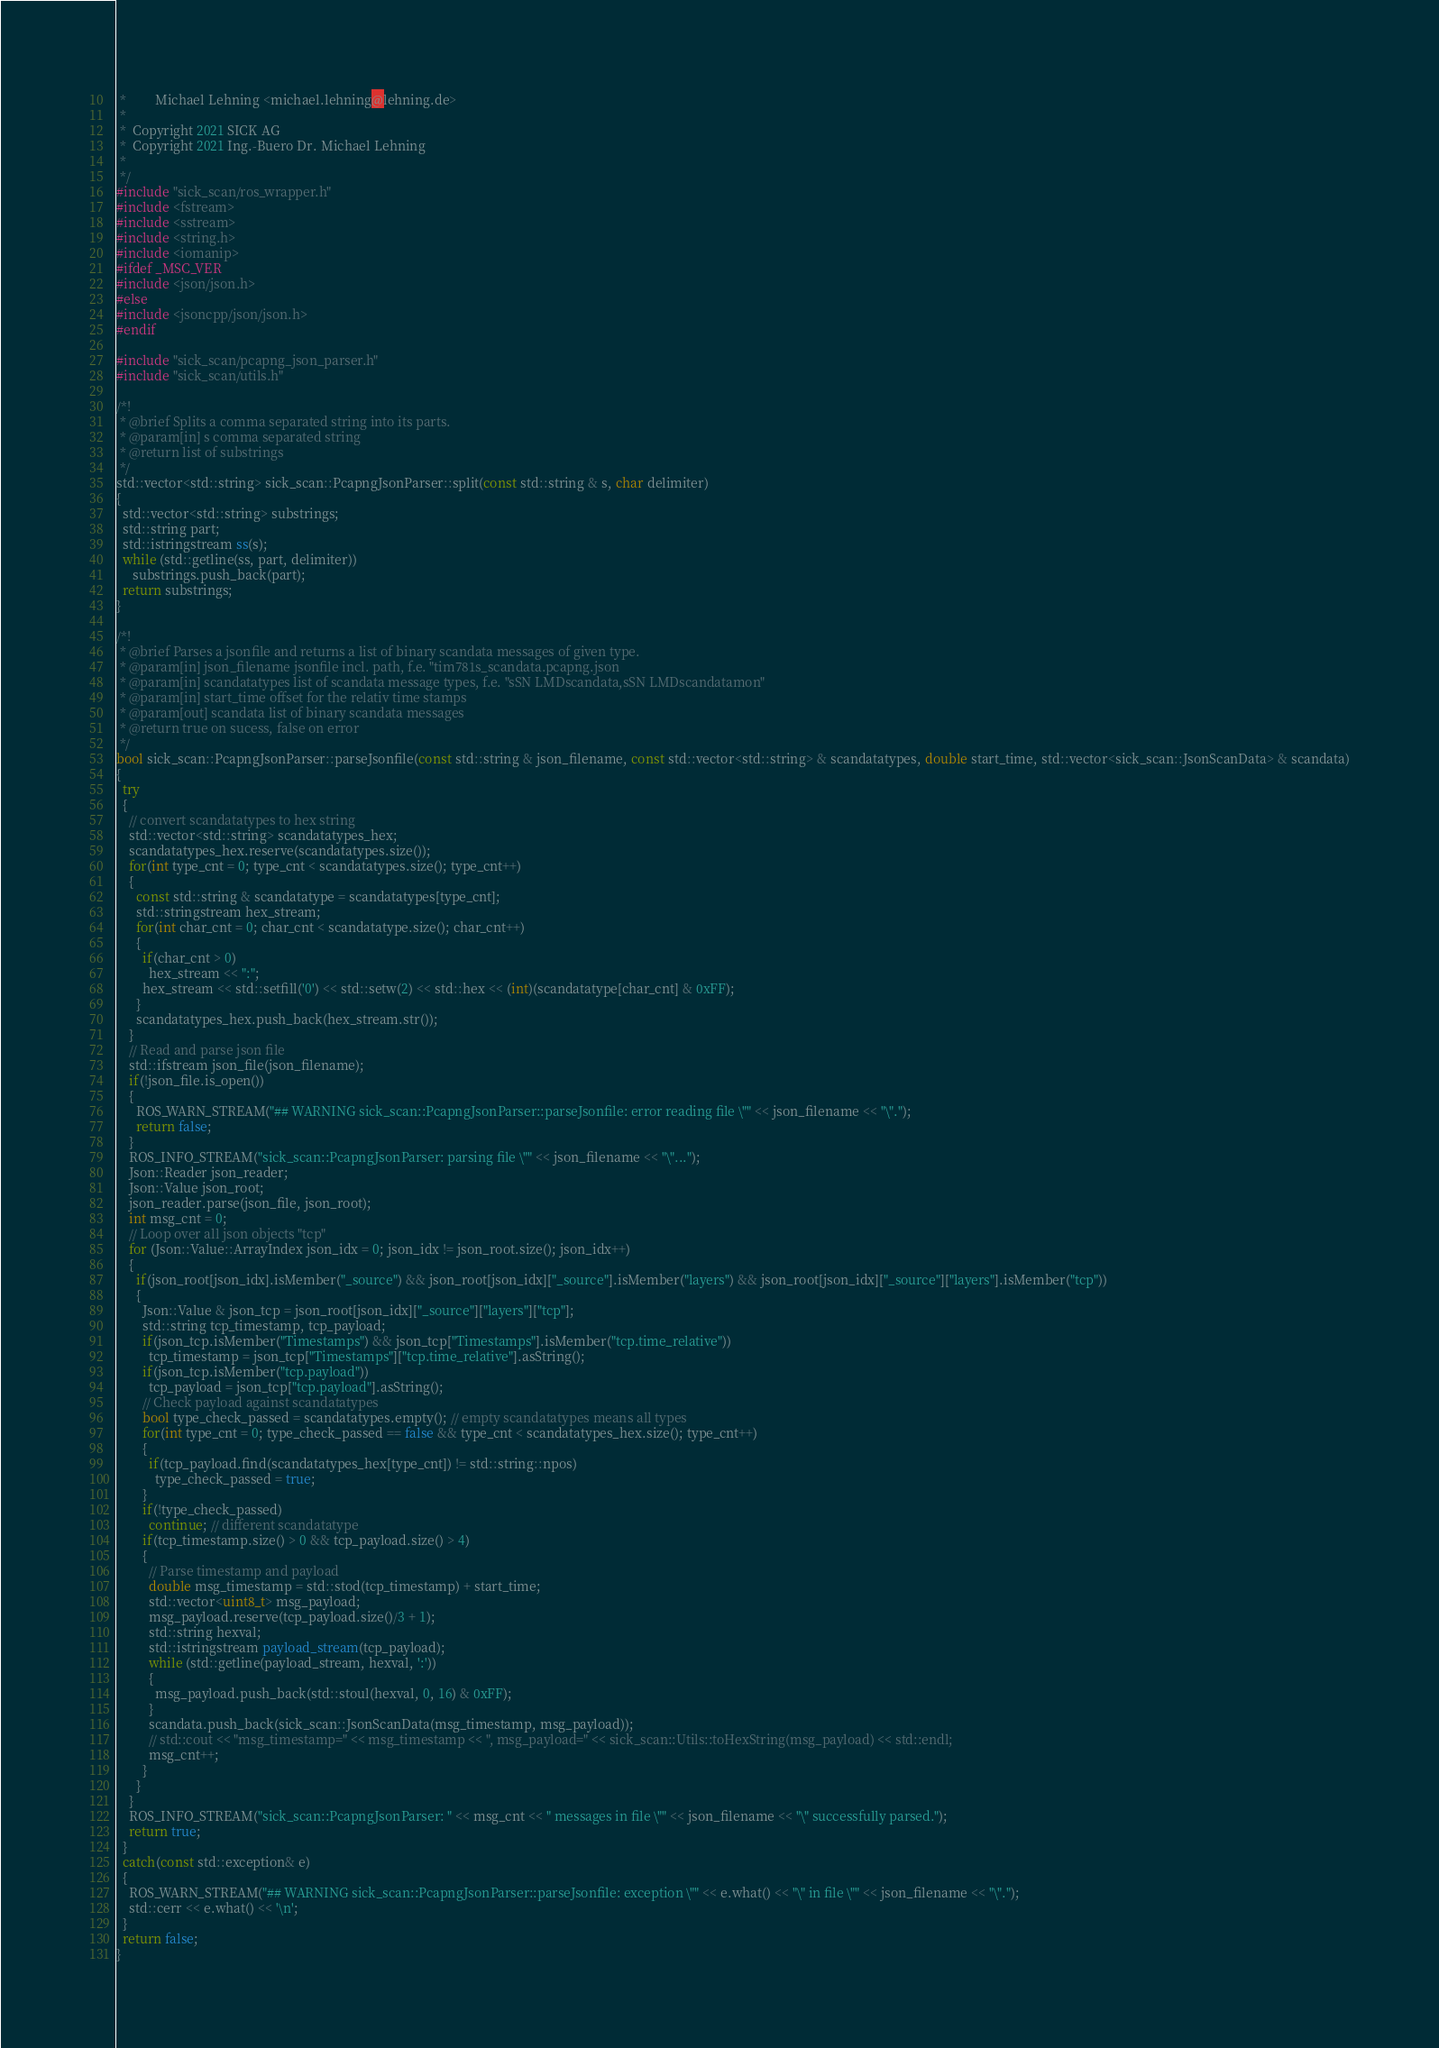Convert code to text. <code><loc_0><loc_0><loc_500><loc_500><_C++_> *         Michael Lehning <michael.lehning@lehning.de>
 *
 *  Copyright 2021 SICK AG
 *  Copyright 2021 Ing.-Buero Dr. Michael Lehning
 *
 */
#include "sick_scan/ros_wrapper.h"
#include <fstream>
#include <sstream>
#include <string.h>
#include <iomanip>
#ifdef _MSC_VER
#include <json/json.h>
#else
#include <jsoncpp/json/json.h>
#endif

#include "sick_scan/pcapng_json_parser.h"
#include "sick_scan/utils.h"

/*!
 * @brief Splits a comma separated string into its parts.
 * @param[in] s comma separated string
 * @return list of substrings
 */
std::vector<std::string> sick_scan::PcapngJsonParser::split(const std::string & s, char delimiter)
{
  std::vector<std::string> substrings;
  std::string part;
  std::istringstream ss(s);
  while (std::getline(ss, part, delimiter))
     substrings.push_back(part);
  return substrings;
}

/*!
 * @brief Parses a jsonfile and returns a list of binary scandata messages of given type.
 * @param[in] json_filename jsonfile incl. path, f.e. "tim781s_scandata.pcapng.json
 * @param[in] scandatatypes list of scandata message types, f.e. "sSN LMDscandata,sSN LMDscandatamon"
 * @param[in] start_time offset for the relativ time stamps
 * @param[out] scandata list of binary scandata messages
 * @return true on sucess, false on error
 */
bool sick_scan::PcapngJsonParser::parseJsonfile(const std::string & json_filename, const std::vector<std::string> & scandatatypes, double start_time, std::vector<sick_scan::JsonScanData> & scandata)
{
  try
  {
    // convert scandatatypes to hex string
    std::vector<std::string> scandatatypes_hex;
    scandatatypes_hex.reserve(scandatatypes.size());
    for(int type_cnt = 0; type_cnt < scandatatypes.size(); type_cnt++)
    {
      const std::string & scandatatype = scandatatypes[type_cnt];
      std::stringstream hex_stream;
      for(int char_cnt = 0; char_cnt < scandatatype.size(); char_cnt++)
      {
        if(char_cnt > 0)
          hex_stream << ":";
        hex_stream << std::setfill('0') << std::setw(2) << std::hex << (int)(scandatatype[char_cnt] & 0xFF);
      }
      scandatatypes_hex.push_back(hex_stream.str());
    }
    // Read and parse json file
    std::ifstream json_file(json_filename);
    if(!json_file.is_open())
    {
      ROS_WARN_STREAM("## WARNING sick_scan::PcapngJsonParser::parseJsonfile: error reading file \"" << json_filename << "\".");   
      return false;
    }
    ROS_INFO_STREAM("sick_scan::PcapngJsonParser: parsing file \"" << json_filename << "\"...");
    Json::Reader json_reader;
    Json::Value json_root;
    json_reader.parse(json_file, json_root);
    int msg_cnt = 0;
    // Loop over all json objects "tcp"
    for (Json::Value::ArrayIndex json_idx = 0; json_idx != json_root.size(); json_idx++)
    {
      if(json_root[json_idx].isMember("_source") && json_root[json_idx]["_source"].isMember("layers") && json_root[json_idx]["_source"]["layers"].isMember("tcp"))
      {
        Json::Value & json_tcp = json_root[json_idx]["_source"]["layers"]["tcp"];
        std::string tcp_timestamp, tcp_payload;
        if(json_tcp.isMember("Timestamps") && json_tcp["Timestamps"].isMember("tcp.time_relative"))
          tcp_timestamp = json_tcp["Timestamps"]["tcp.time_relative"].asString();
        if(json_tcp.isMember("tcp.payload"))
          tcp_payload = json_tcp["tcp.payload"].asString();
        // Check payload against scandatatypes
        bool type_check_passed = scandatatypes.empty(); // empty scandatatypes means all types
        for(int type_cnt = 0; type_check_passed == false && type_cnt < scandatatypes_hex.size(); type_cnt++)
        {
          if(tcp_payload.find(scandatatypes_hex[type_cnt]) != std::string::npos)
            type_check_passed = true;
        }
        if(!type_check_passed)
          continue; // different scandatatype
        if(tcp_timestamp.size() > 0 && tcp_payload.size() > 4)
        {
          // Parse timestamp and payload
          double msg_timestamp = std::stod(tcp_timestamp) + start_time;
          std::vector<uint8_t> msg_payload;
          msg_payload.reserve(tcp_payload.size()/3 + 1);
          std::string hexval;
          std::istringstream payload_stream(tcp_payload);
          while (std::getline(payload_stream, hexval, ':'))
          {
            msg_payload.push_back(std::stoul(hexval, 0, 16) & 0xFF);
          }
          scandata.push_back(sick_scan::JsonScanData(msg_timestamp, msg_payload));
          // std::cout << "msg_timestamp=" << msg_timestamp << ", msg_payload=" << sick_scan::Utils::toHexString(msg_payload) << std::endl;
          msg_cnt++;
        }
      }
    }
    ROS_INFO_STREAM("sick_scan::PcapngJsonParser: " << msg_cnt << " messages in file \"" << json_filename << "\" successfully parsed.");   
    return true;
  }
  catch(const std::exception& e)
  {
    ROS_WARN_STREAM("## WARNING sick_scan::PcapngJsonParser::parseJsonfile: exception \"" << e.what() << "\" in file \"" << json_filename << "\".");   
    std::cerr << e.what() << '\n';
  }
  return false;
}
</code> 